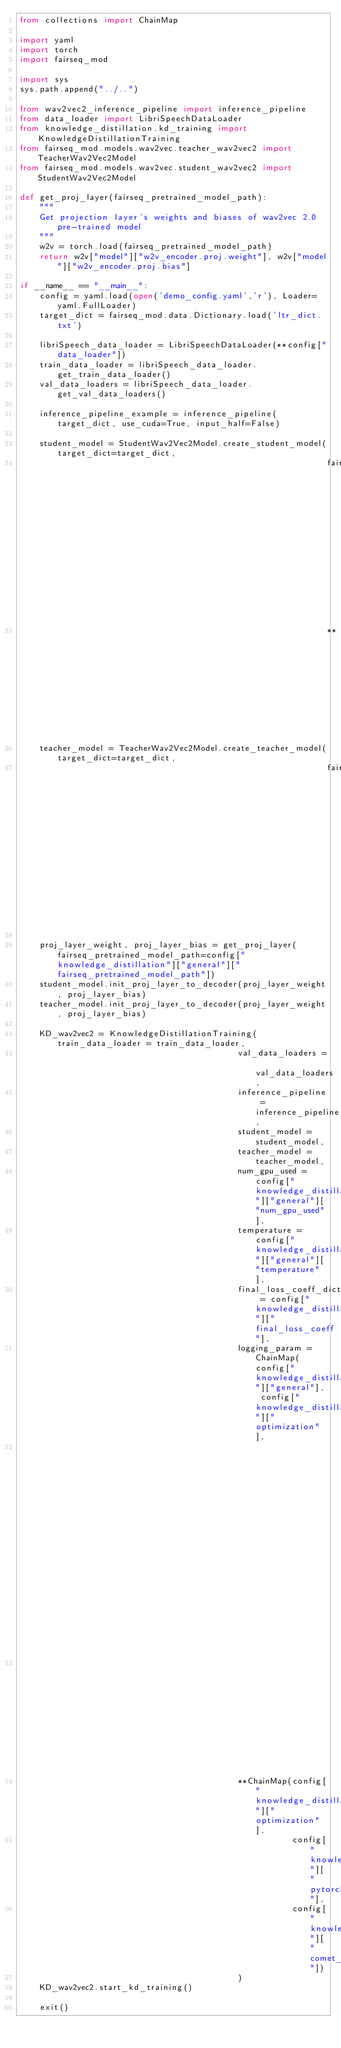<code> <loc_0><loc_0><loc_500><loc_500><_Python_>from collections import ChainMap

import yaml
import torch
import fairseq_mod

import sys
sys.path.append("../..")

from wav2vec2_inference_pipeline import inference_pipeline
from data_loader import LibriSpeechDataLoader
from knowledge_distillation.kd_training import KnowledgeDistillationTraining
from fairseq_mod.models.wav2vec.teacher_wav2vec2 import TeacherWav2Vec2Model
from fairseq_mod.models.wav2vec.student_wav2vec2 import StudentWav2Vec2Model

def get_proj_layer(fairseq_pretrained_model_path):
    """
    Get projection layer's weights and biases of wav2vec 2.0 pre-trained model
    """
    w2v = torch.load(fairseq_pretrained_model_path)
    return w2v["model"]["w2v_encoder.proj.weight"], w2v["model"]["w2v_encoder.proj.bias"]

if __name__ == "__main__":
    config = yaml.load(open('demo_config.yaml','r'), Loader=yaml.FullLoader)
    target_dict = fairseq_mod.data.Dictionary.load('ltr_dict.txt')

    libriSpeech_data_loader = LibriSpeechDataLoader(**config["data_loader"])
    train_data_loader = libriSpeech_data_loader.get_train_data_loader()
    val_data_loaders = libriSpeech_data_loader.get_val_data_loaders()

    inference_pipeline_example = inference_pipeline(target_dict, use_cuda=True, input_half=False)

    student_model = StudentWav2Vec2Model.create_student_model(target_dict=target_dict,
                                                              fairseq_pretrained_model_path=config["knowledge_distillation"]["general"]["fairseq_pretrained_model_path"],
                                                              **config["knowledge_distillation"]["student_model"])
    teacher_model = TeacherWav2Vec2Model.create_teacher_model(target_dict=target_dict,
                                                              fairseq_pretrained_model_path=config["knowledge_distillation"]["general"]["fairseq_pretrained_model_path"])

    proj_layer_weight, proj_layer_bias = get_proj_layer(fairseq_pretrained_model_path=config["knowledge_distillation"]["general"]["fairseq_pretrained_model_path"])
    student_model.init_proj_layer_to_decoder(proj_layer_weight, proj_layer_bias)
    teacher_model.init_proj_layer_to_decoder(proj_layer_weight, proj_layer_bias)

    KD_wav2vec2 = KnowledgeDistillationTraining(train_data_loader = train_data_loader,
                                            val_data_loaders = val_data_loaders,
                                            inference_pipeline = inference_pipeline_example,
                                            student_model = student_model,
                                            teacher_model = teacher_model,
                                            num_gpu_used = config["knowledge_distillation"]["general"]["num_gpu_used"],
                                            temperature = config["knowledge_distillation"]["general"]["temperature"],
                                            final_loss_coeff_dict = config["knowledge_distillation"]["final_loss_coeff"],
                                            logging_param = ChainMap(config["knowledge_distillation"]["general"], config["knowledge_distillation"]["optimization"],
                                                                     config["knowledge_distillation"]["final_loss_coeff"], config["knowledge_distillation"]["student_model"],
                                                                     config["knowledge_distillation"]["pytorch_lightning_trainer"]),
                                            **ChainMap(config["knowledge_distillation"]["optimization"],
                                                       config["knowledge_distillation"]["pytorch_lightning_trainer"],
                                                       config["knowledge_distillation"]["comet_info"])
                                            )
    KD_wav2vec2.start_kd_training()

    exit()</code> 